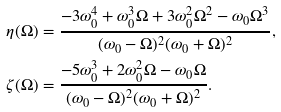Convert formula to latex. <formula><loc_0><loc_0><loc_500><loc_500>\eta ( \Omega ) & = \frac { - 3 \omega _ { 0 } ^ { 4 } + \omega _ { 0 } ^ { 3 } \Omega + 3 \omega _ { 0 } ^ { 2 } \Omega ^ { 2 } - \omega _ { 0 } \Omega ^ { 3 } } { ( \omega _ { 0 } - \Omega ) ^ { 2 } ( \omega _ { 0 } + \Omega ) ^ { 2 } } , \\ \zeta ( \Omega ) & = \frac { - 5 \omega _ { 0 } ^ { 3 } + 2 \omega _ { 0 } ^ { 2 } \Omega - \omega _ { 0 } \Omega } { ( \omega _ { 0 } - \Omega ) ^ { 2 } ( \omega _ { 0 } + \Omega ) ^ { 2 } } .</formula> 